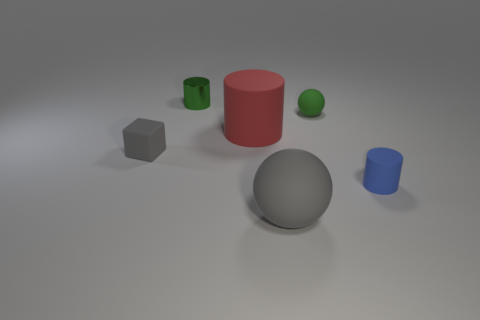Are there an equal number of rubber cylinders that are left of the gray matte ball and big cylinders left of the gray cube?
Your answer should be compact. No. There is a small cylinder to the right of the tiny shiny object; what is its material?
Your response must be concise. Rubber. Are there any other things that are the same size as the green ball?
Your answer should be very brief. Yes. Are there fewer small cylinders than big purple matte cylinders?
Your response must be concise. No. The small thing that is both in front of the green ball and on the left side of the tiny blue matte thing has what shape?
Offer a terse response. Cube. How many green objects are there?
Your answer should be very brief. 2. What is the material of the green thing that is left of the object in front of the tiny cylinder that is right of the small green metal thing?
Provide a succinct answer. Metal. How many small green cylinders are on the left side of the small cylinder behind the tiny gray matte block?
Your answer should be compact. 0. There is another large object that is the same shape as the metallic thing; what color is it?
Your answer should be very brief. Red. Does the large gray thing have the same material as the large red cylinder?
Make the answer very short. Yes. 